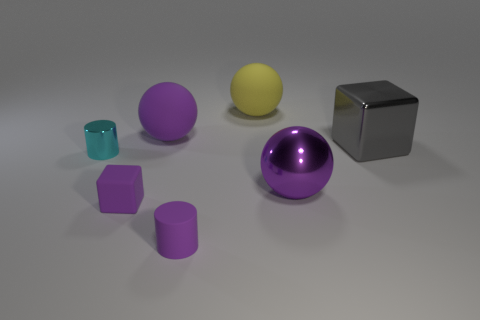Can you describe the arrangement of the objects? The objects are arranged in a somewhat scattered formation, but with clear space between them. They vary in shapes and colors; there are spheres, cubes, and cylindrical shapes, in colors like purple, gray, yellow, and teal. Do the objects have any patterns or textures on them? No discernible patterns or textures are present on the objects' surfaces. They all appear to have smooth finishes, with differing sheens ranging from matte to high gloss. 